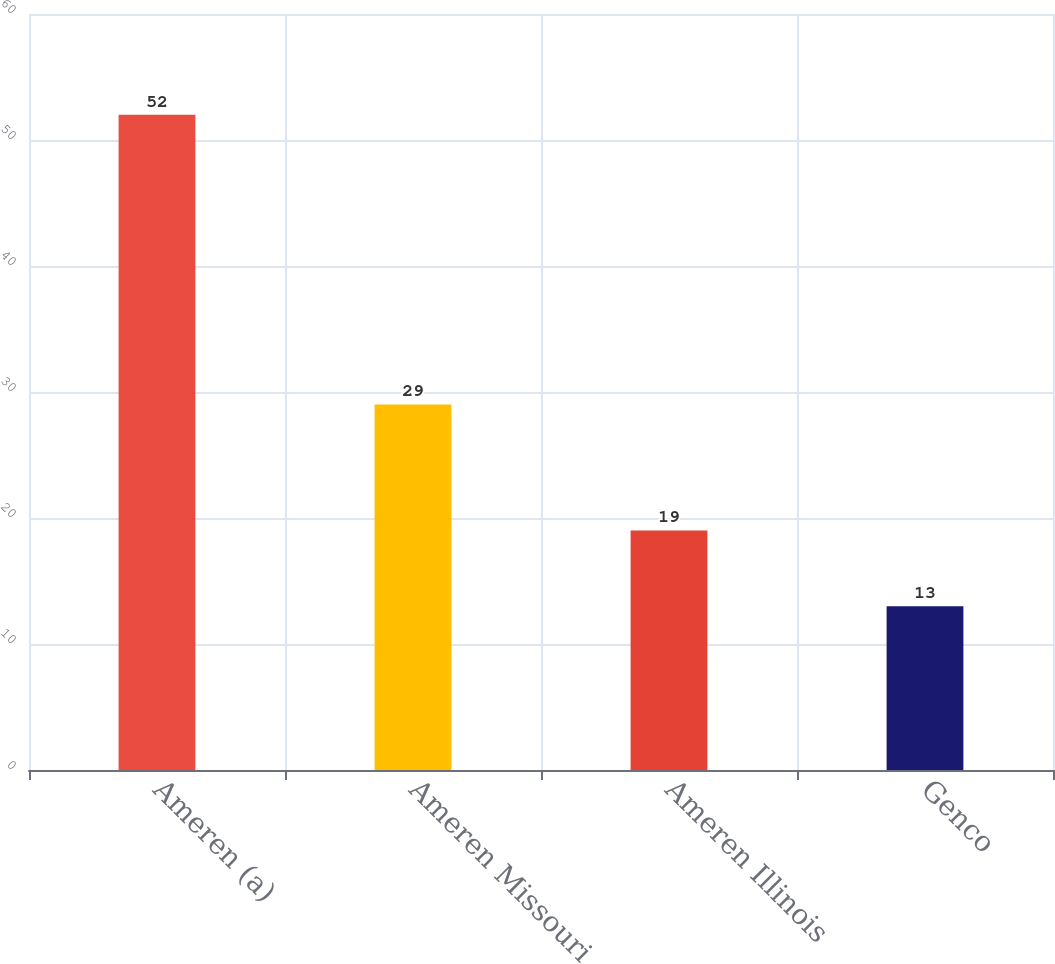Convert chart to OTSL. <chart><loc_0><loc_0><loc_500><loc_500><bar_chart><fcel>Ameren (a)<fcel>Ameren Missouri<fcel>Ameren Illinois<fcel>Genco<nl><fcel>52<fcel>29<fcel>19<fcel>13<nl></chart> 